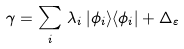Convert formula to latex. <formula><loc_0><loc_0><loc_500><loc_500>\gamma = \sum _ { i } \, \lambda _ { i } \, | \phi _ { i } \rangle \langle \phi _ { i } | + \Delta _ { \varepsilon }</formula> 